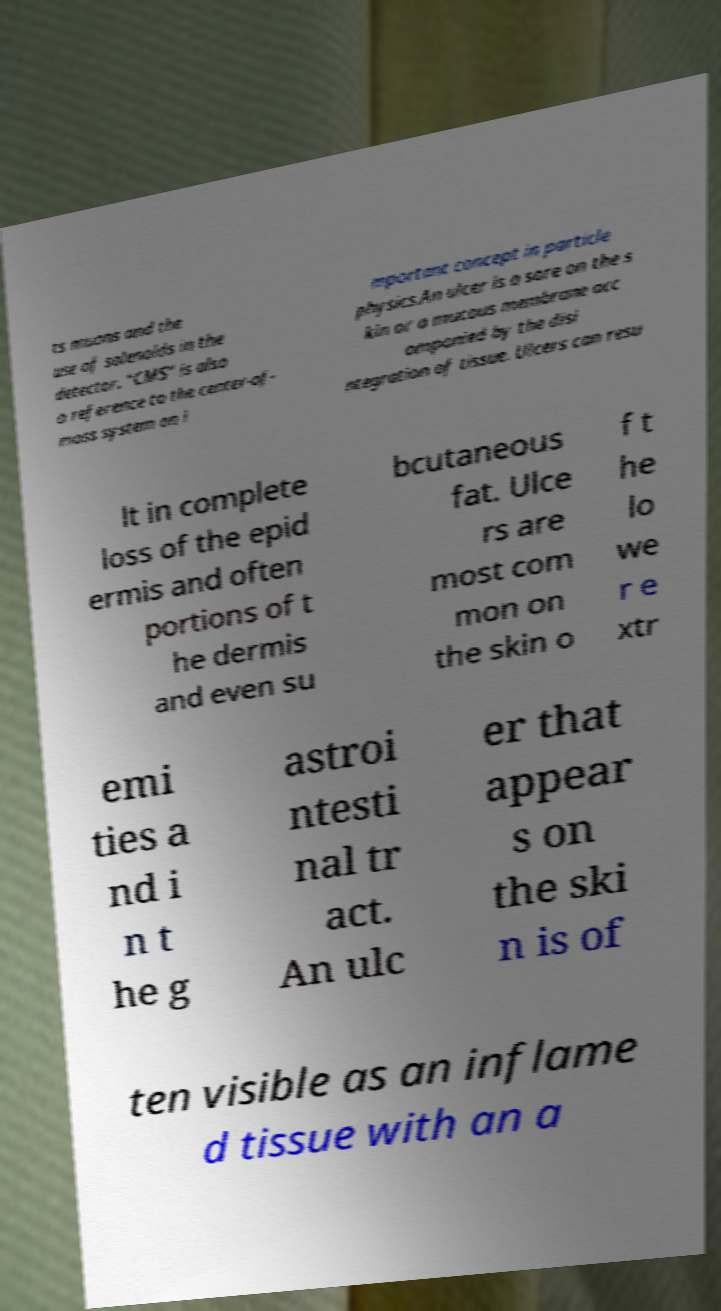Please identify and transcribe the text found in this image. ts muons and the use of solenoids in the detector. "CMS" is also a reference to the center-of- mass system an i mportant concept in particle physics.An ulcer is a sore on the s kin or a mucous membrane acc ompanied by the disi ntegration of tissue. Ulcers can resu lt in complete loss of the epid ermis and often portions of t he dermis and even su bcutaneous fat. Ulce rs are most com mon on the skin o f t he lo we r e xtr emi ties a nd i n t he g astroi ntesti nal tr act. An ulc er that appear s on the ski n is of ten visible as an inflame d tissue with an a 